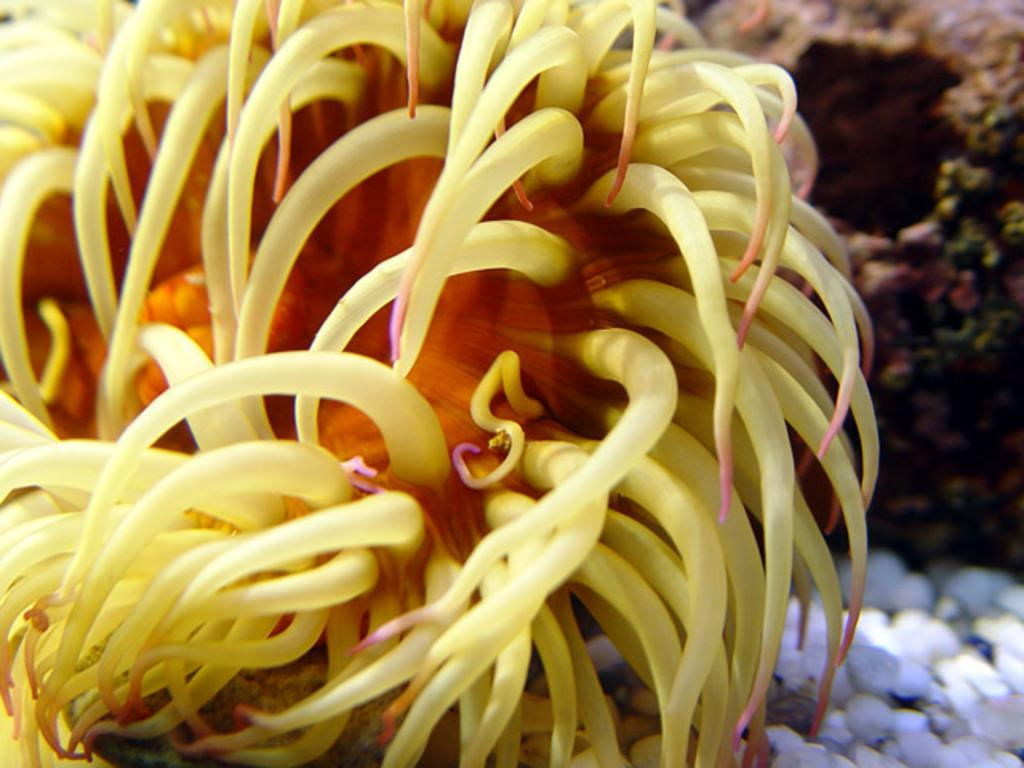What type of plant is in the picture? There is a marine plant in the picture. What color is the marine plant? The marine plant is yellow in color. Can you describe the background of the image? The background of the image is blurred. How many grapes are hanging from the marine plant in the image? There are no grapes present in the image, as it features a marine plant. Is there a light source visible in the image? There is no mention of a light source in the provided facts, so we cannot determine if one is visible in the image. 